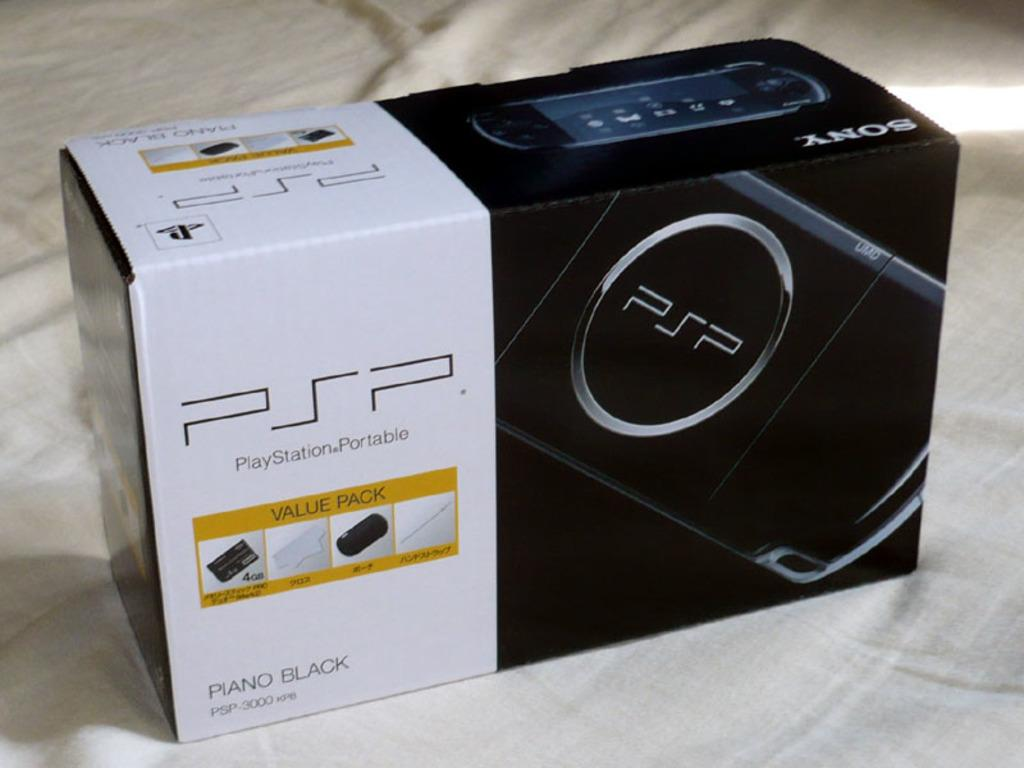<image>
Relay a brief, clear account of the picture shown. The shown computer console pack is a value pack. 